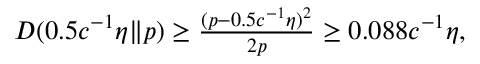<formula> <loc_0><loc_0><loc_500><loc_500>\begin{array} { r } { D ( 0 . 5 c ^ { - 1 } \eta \| p ) \geq \frac { ( p - 0 . 5 c ^ { - 1 } \eta ) ^ { 2 } } { 2 p } \geq 0 . 0 8 8 c ^ { - 1 } \eta , } \end{array}</formula> 